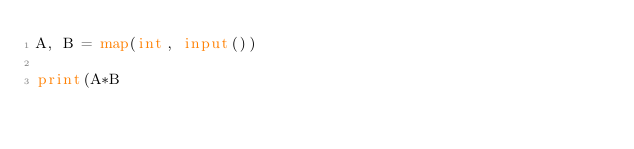Convert code to text. <code><loc_0><loc_0><loc_500><loc_500><_Python_>A, B = map(int, input())

print(A*B</code> 